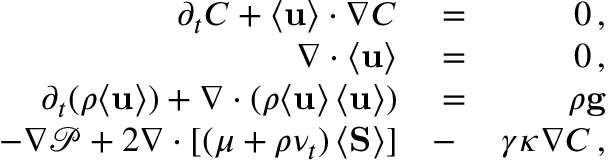<formula> <loc_0><loc_0><loc_500><loc_500>\begin{array} { r l r } { \partial _ { t } C + \langle { u } \rangle \cdot \nabla C } & = } & { 0 \, , } \\ { \nabla \cdot \langle { u } \rangle } & = } & { 0 \, , } \\ { \partial _ { t } ( \rho \langle { u } \rangle ) + \nabla \cdot ( \rho \langle { u } \rangle \, \langle { u } \rangle ) } & = } & { \rho { g } } \\ { - \nabla \mathcal { P } + 2 \nabla \cdot [ ( \mu + \rho \nu _ { t } ) \, \langle { S } \rangle ] } & - } & { \gamma \kappa \nabla C \, , } \end{array}</formula> 